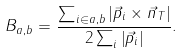Convert formula to latex. <formula><loc_0><loc_0><loc_500><loc_500>B _ { a , b } = \frac { \sum _ { i \in a , b } \left | \vec { p } _ { i } \times \vec { n } _ { T } \right | } { 2 \sum _ { i } \left | \vec { p } _ { i } \right | } .</formula> 